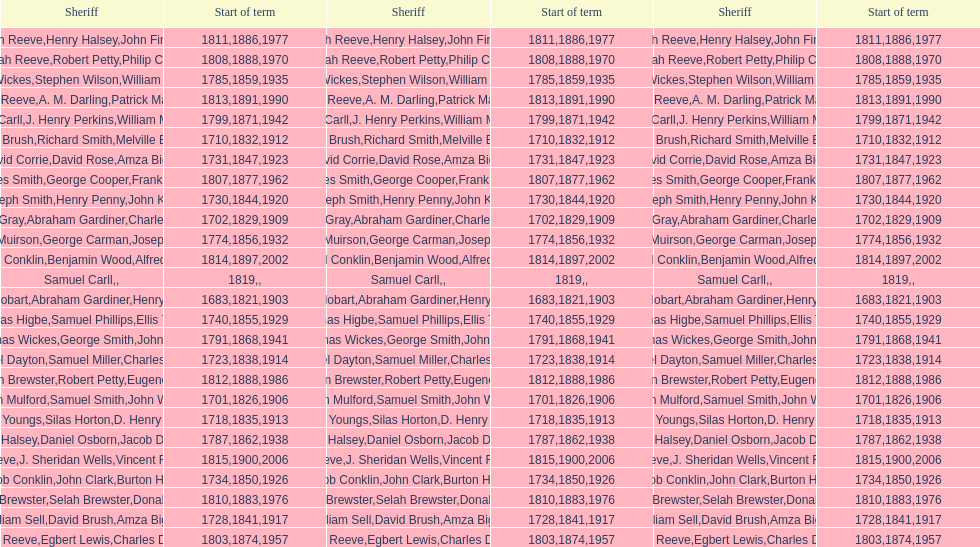How sheriffs has suffolk county had in total? 76. 